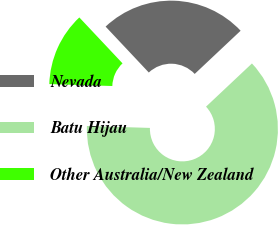Convert chart. <chart><loc_0><loc_0><loc_500><loc_500><pie_chart><fcel>Nevada<fcel>Batu Hijau<fcel>Other Australia/New Zealand<nl><fcel>25.0%<fcel>62.5%<fcel>12.5%<nl></chart> 